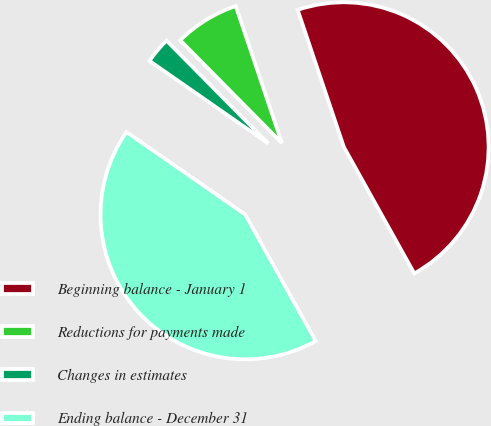Convert chart to OTSL. <chart><loc_0><loc_0><loc_500><loc_500><pie_chart><fcel>Beginning balance - January 1<fcel>Reductions for payments made<fcel>Changes in estimates<fcel>Ending balance - December 31<nl><fcel>47.08%<fcel>7.24%<fcel>2.92%<fcel>42.76%<nl></chart> 